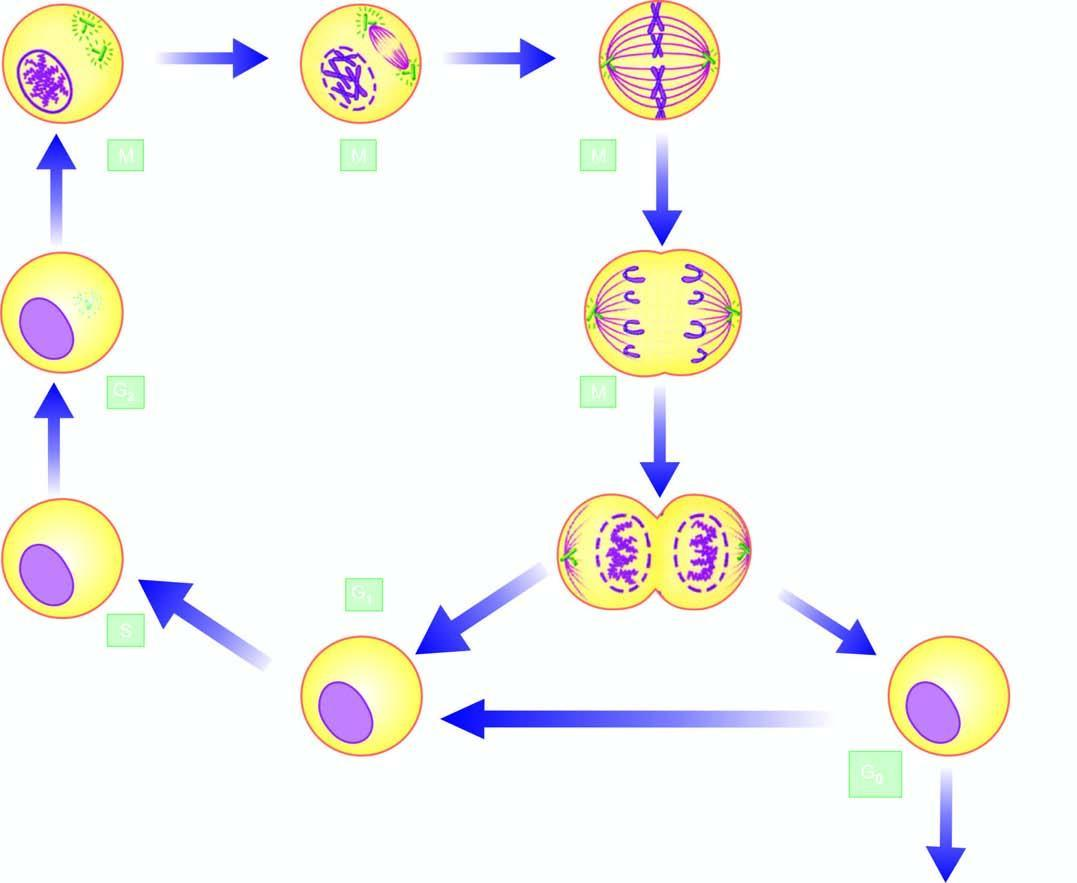re premitotic phases the g1, s and g2 phase while m phase is accomplished in 4 sequential stages: prophase, metaphase, anaphase, and telophase?
Answer the question using a single word or phrase. Yes 